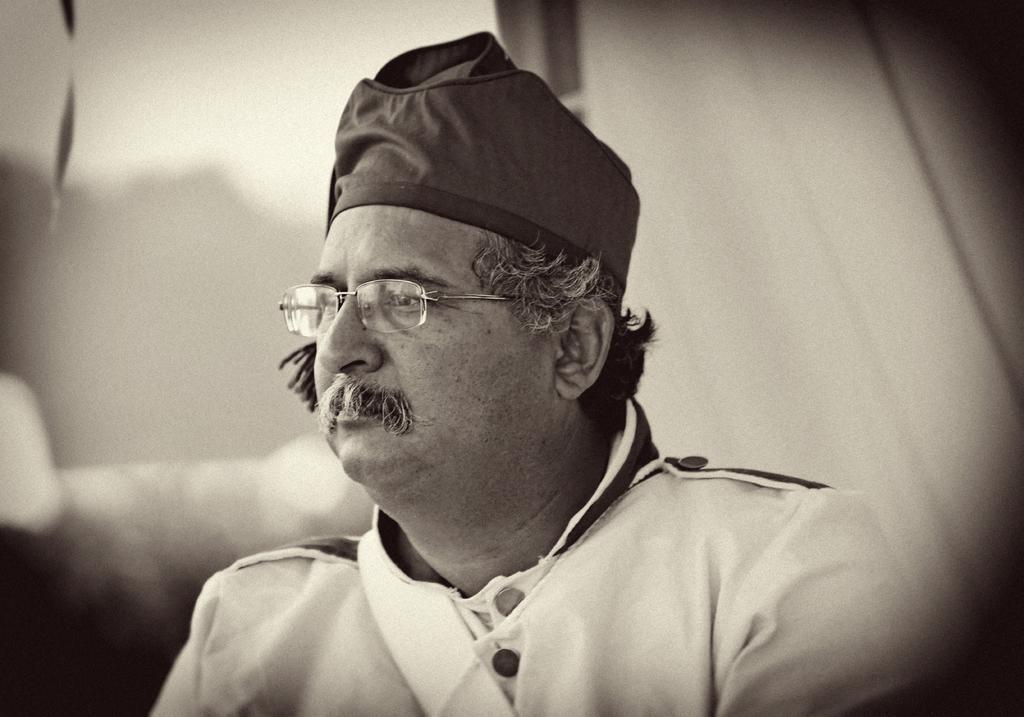Could you give a brief overview of what you see in this image? In the image there is an old man with cap on his head, this is a black and picture, he had glasses over his eyes. 